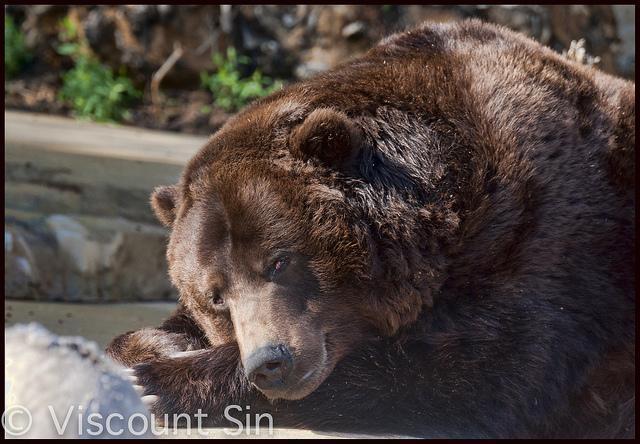How many bears?
Give a very brief answer. 1. How many of these animals have paws?
Give a very brief answer. 1. How many bears do you see?
Give a very brief answer. 1. 